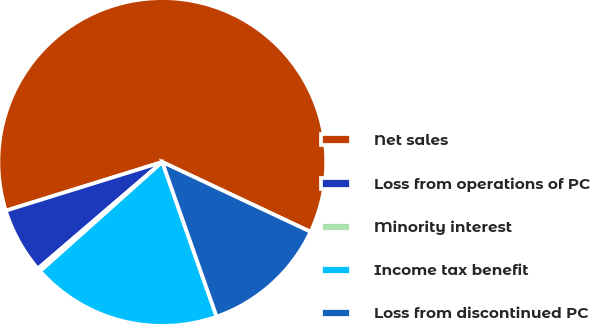Convert chart to OTSL. <chart><loc_0><loc_0><loc_500><loc_500><pie_chart><fcel>Net sales<fcel>Loss from operations of PC<fcel>Minority interest<fcel>Income tax benefit<fcel>Loss from discontinued PC<nl><fcel>61.8%<fcel>6.48%<fcel>0.33%<fcel>18.77%<fcel>12.62%<nl></chart> 